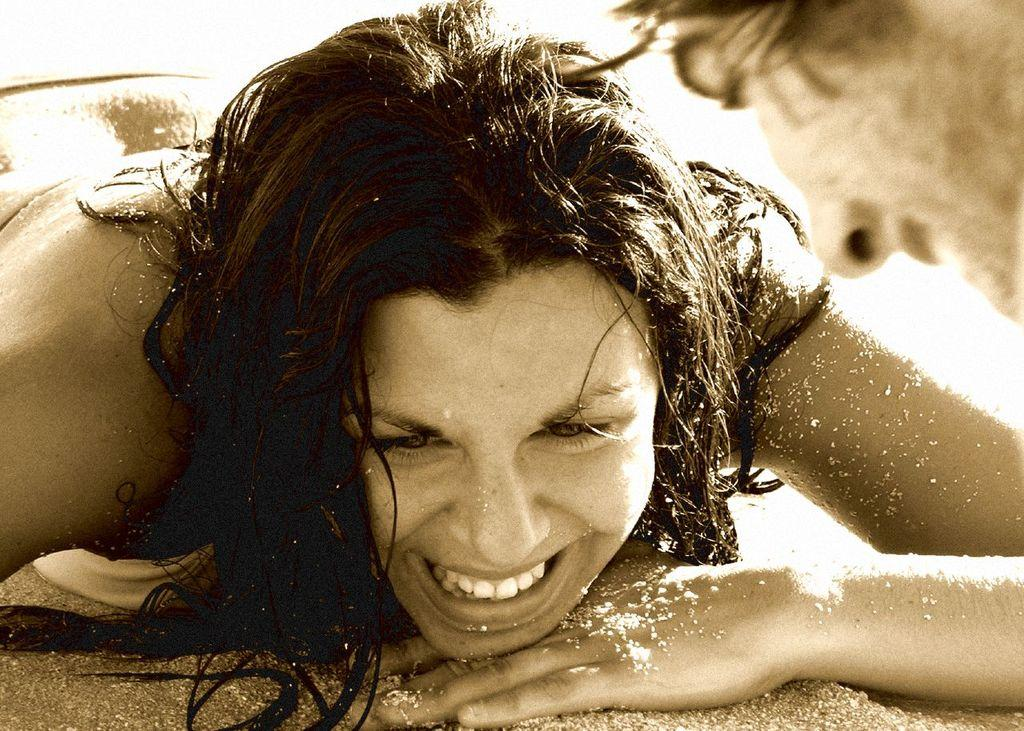Who is present in the image? There is a woman in the image. What is the woman's facial expression? The woman is smiling. What type of surface is at the bottom of the image? There is sand at the bottom of the image. Can you describe the person's face visible on the right side of the image? There is a person's face visible on the right side of the image. What type of mint can be seen growing in the sand in the image? There is no mint visible in the image; it only shows sand at the bottom. 